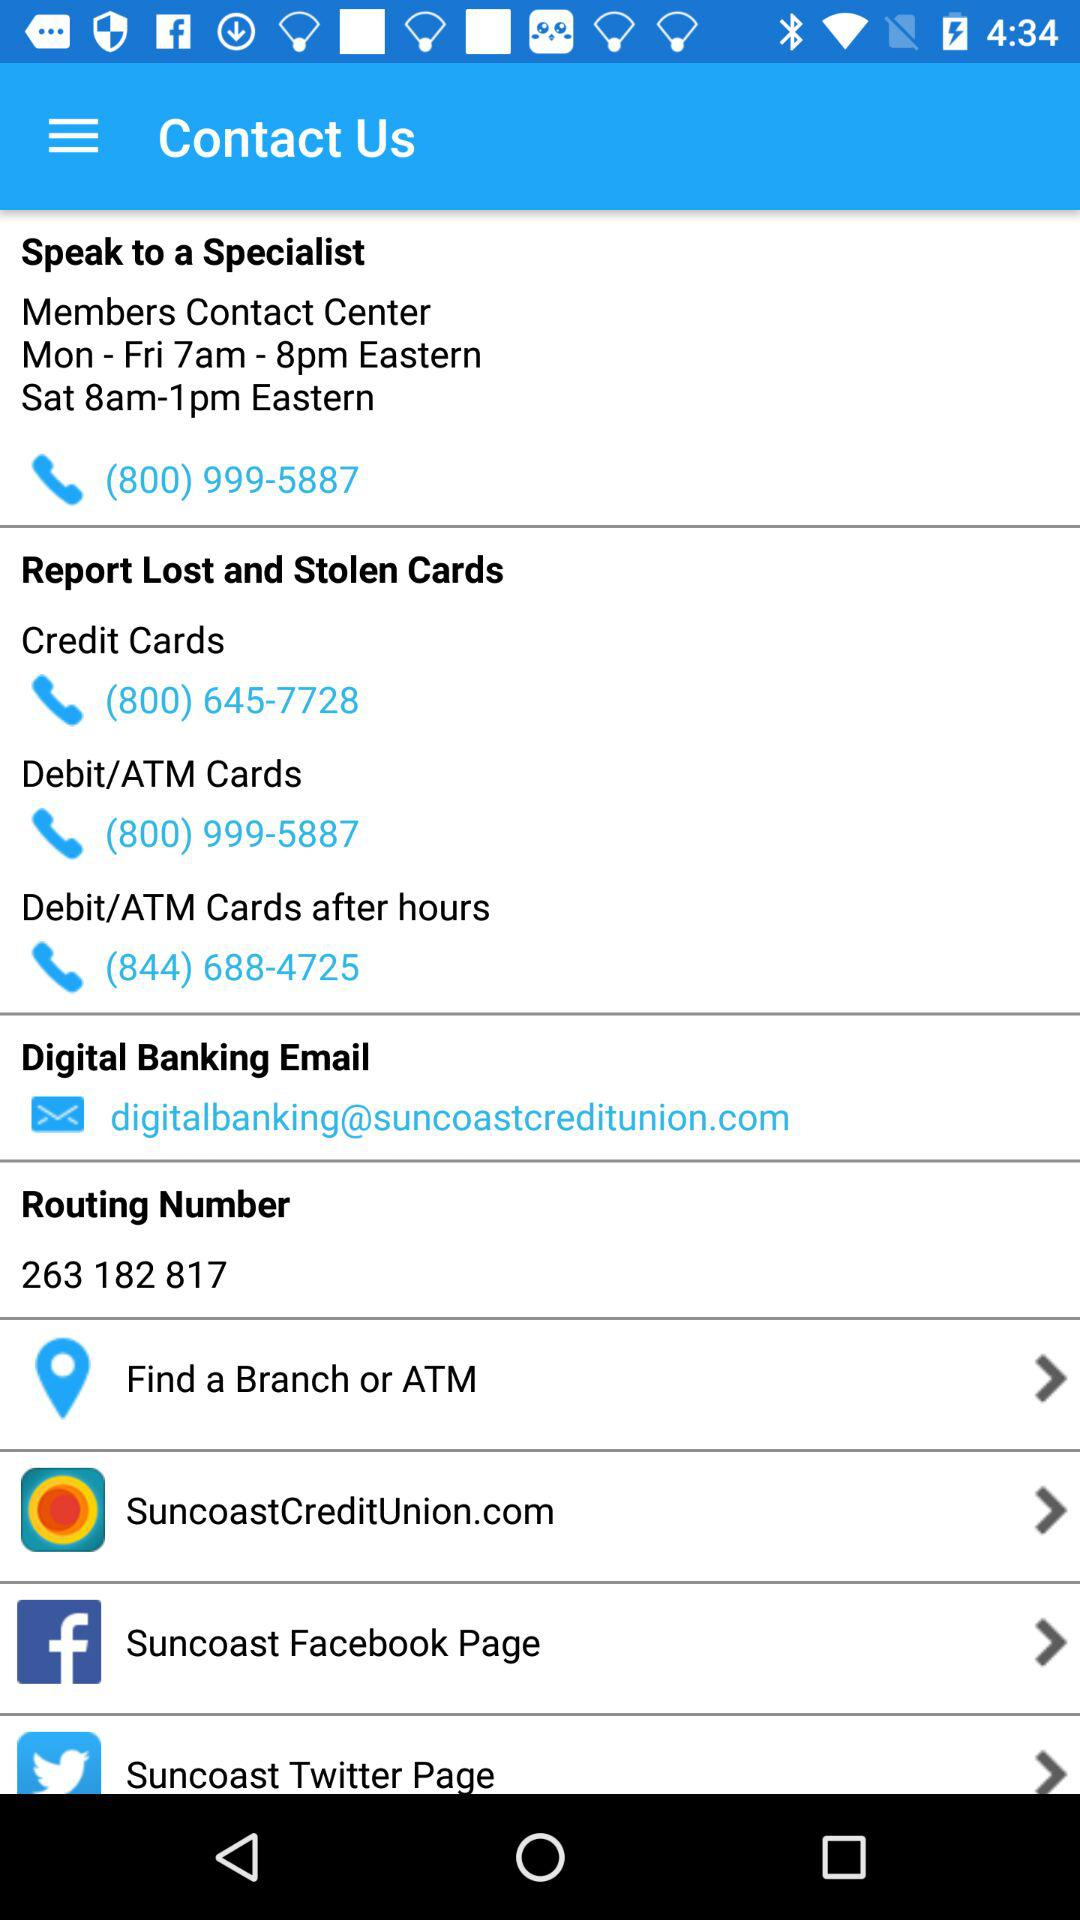What are the hours to contact the "Members Contact Center" on Saturdays? The hours to contact the "Members Contact Center" on Saturdays are from 8 a.m. to 1 p.m. Eastern. 